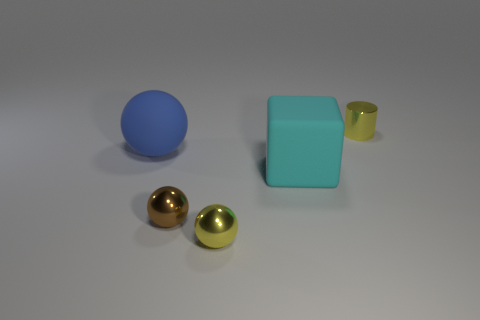What number of other things are the same shape as the brown metallic object?
Your response must be concise. 2. What number of things are either objects that are left of the metal cylinder or shiny objects that are behind the brown thing?
Give a very brief answer. 5. How many other things are there of the same color as the small cylinder?
Give a very brief answer. 1. Are there fewer brown shiny spheres that are to the right of the small brown ball than matte things to the left of the tiny yellow metallic sphere?
Give a very brief answer. Yes. What number of large cyan matte blocks are there?
Offer a very short reply. 1. Is there anything else that is made of the same material as the yellow sphere?
Keep it short and to the point. Yes. What material is the brown thing that is the same shape as the blue thing?
Give a very brief answer. Metal. Is the number of blue rubber balls that are in front of the yellow metallic ball less than the number of tiny red cubes?
Offer a terse response. No. There is a yellow object that is to the left of the large cyan rubber block; does it have the same shape as the big cyan object?
Give a very brief answer. No. Is there any other thing that is the same color as the cylinder?
Provide a succinct answer. Yes. 